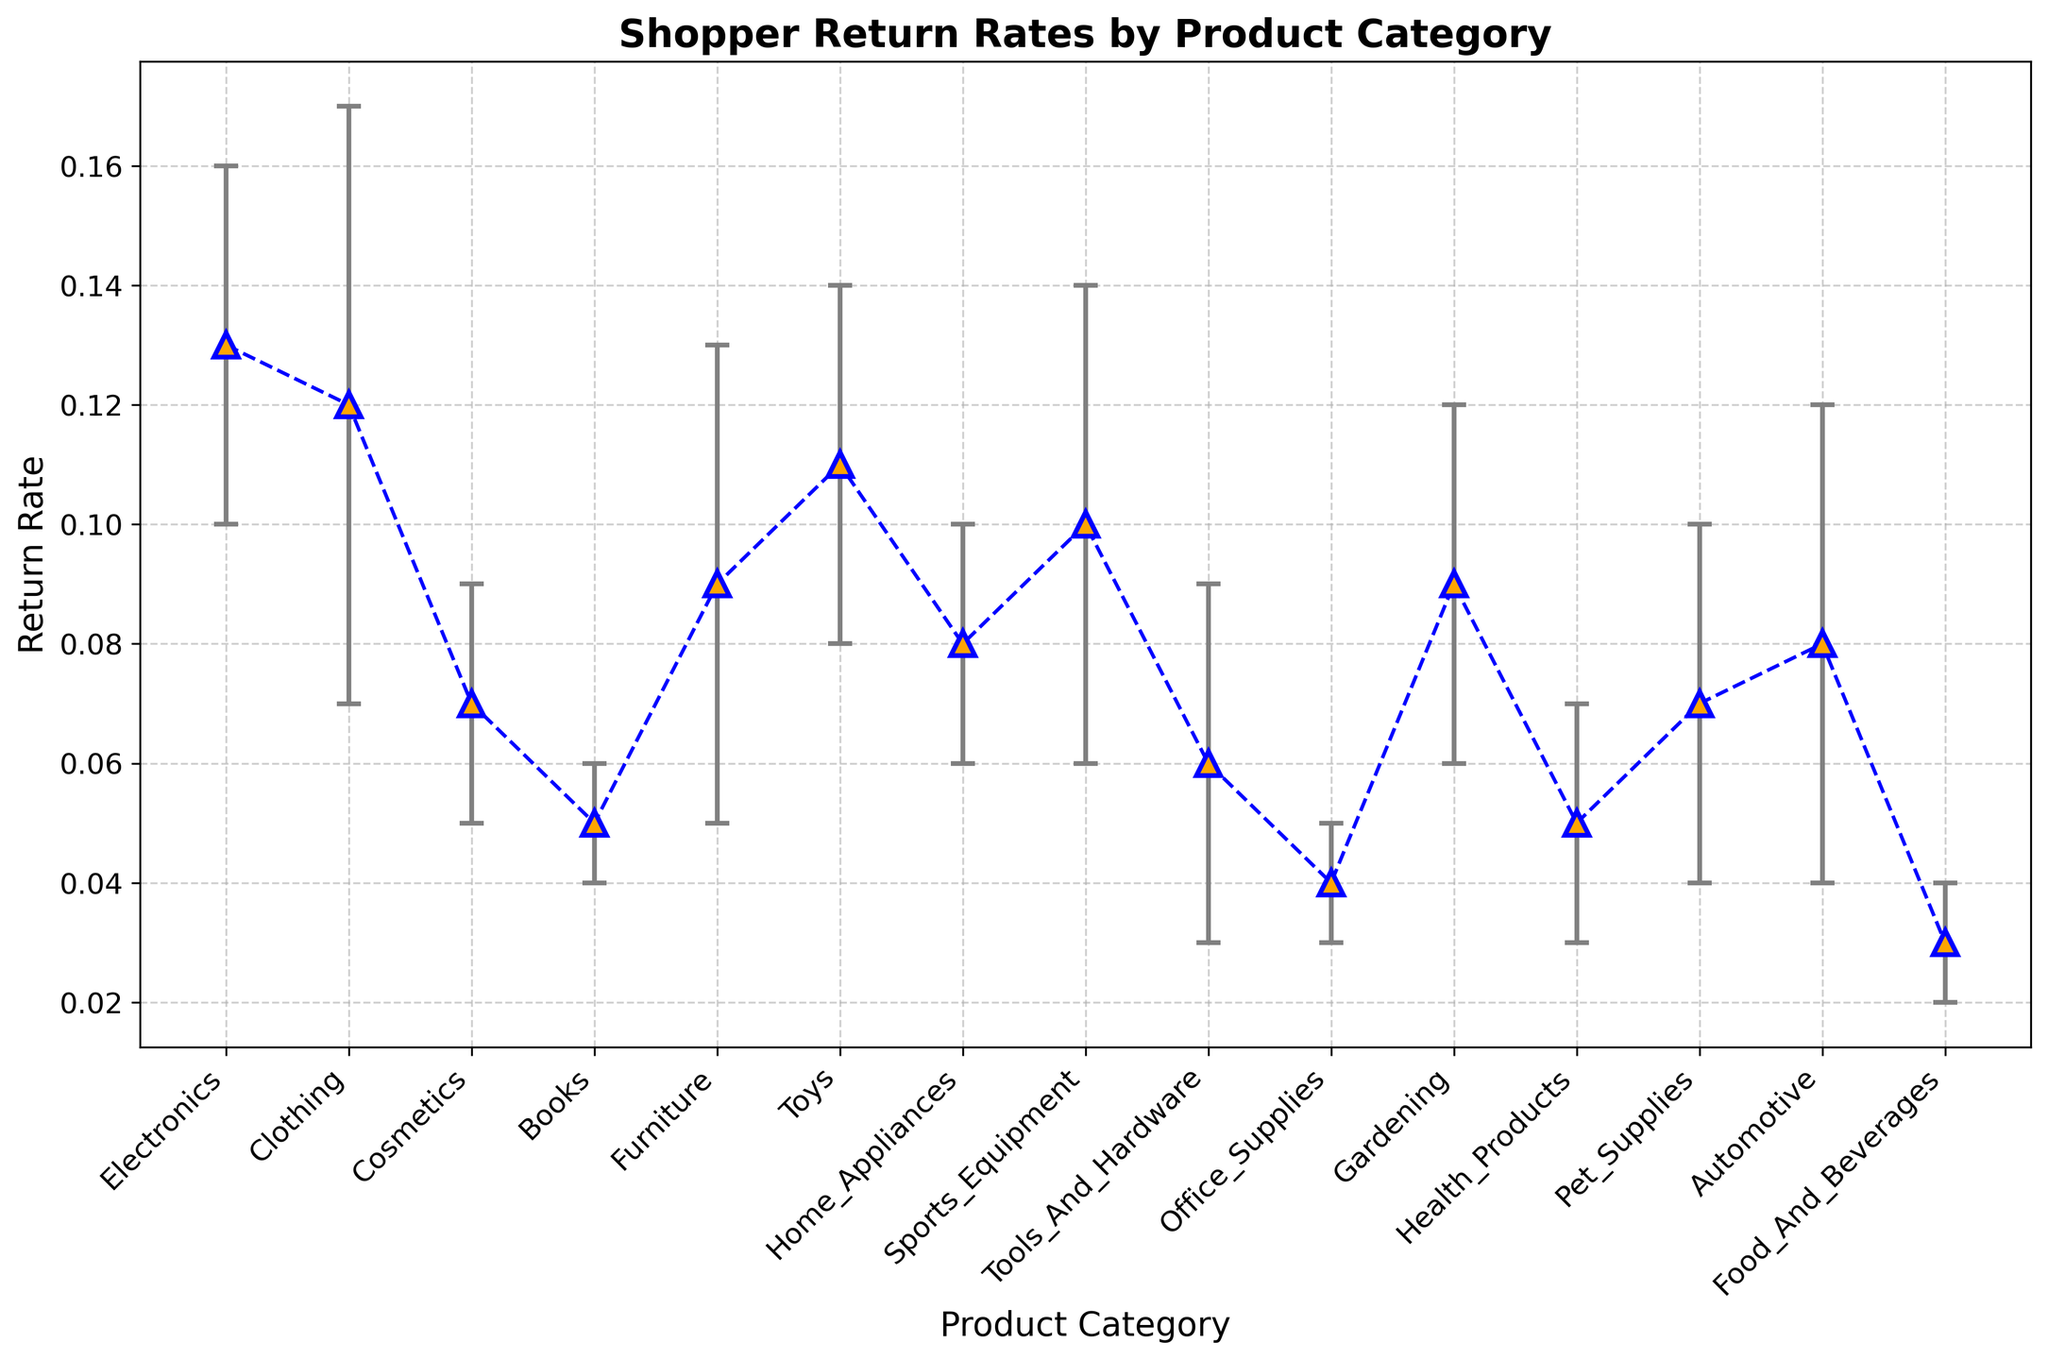Which product category has the highest return rate? By looking at the figure, you can identify the category with the tallest vertical marker. The highest return rate is shown by Electronics.
Answer: Electronics What is the return rate difference between Electronics and Books? From the figure, the return rate for Electronics is 0.13 and for Books is 0.05. Subtract the return rate of Books from Electronics: 0.13 - 0.05 = 0.08
Answer: 0.08 Which two product categories have similar return rates and differ by only 0.01? Examining the plot, Clothing has a return rate of 0.12 and Electronics has a return rate of 0.13. The difference is: 0.13 - 0.12 = 0.01
Answer: Clothing and Electronics Which product category has the smallest standard deviation? By checking the lengths of the error bars, Office Supplies and Food & Beverages both have the shortest error bars, and thus the smallest standard deviation of 0.01.
Answer: Office Supplies, Food & Beverages What is the total return rate for Clothing, Furniture, and Toys combined? Return rates for Clothing (0.12), Furniture (0.09), and Toys (0.11). Add them up: 0.12 + 0.09 + 0.11 = 0.32
Answer: 0.32 Which product category shows the largest uncertainty in return rates? Observing the lengths of the error bars, Clothing has the longest error bar with a standard deviation of 0.05, indicating the largest uncertainty.
Answer: Clothing What is the average return rate across all product categories? Sum all return rates and divide by the number of categories: (0.13 + 0.12 + 0.07 + 0.05 + 0.09 + 0.11 + 0.08 + 0.10 + 0.06 + 0.04 + 0.09 + 0.05 + 0.07 + 0.08 + 0.03) / 15 ≈ 0.078
Answer: 0.078 